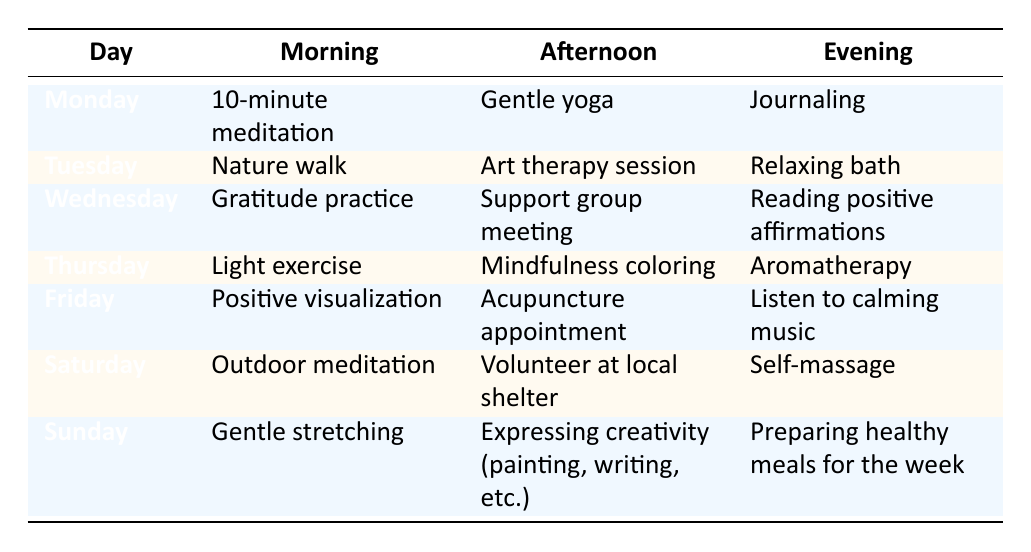What self-care activity is scheduled for Monday evening? By looking at the evening column for Monday, the activity listed is "Journaling."
Answer: Journaling Which day includes both a nature walk and an art therapy session? In the table, "Nature walk" is scheduled for Tuesday morning and "Art therapy session" is scheduled for Tuesday afternoon, indicating that both are on the same day.
Answer: Tuesday Is there a support group meeting scheduled for the week? The table shows that there is a "Support group meeting" on Wednesday afternoon, so the answer is yes.
Answer: Yes On which day is the 10-minute meditation scheduled? Referring to the morning column, "10-minute meditation" is scheduled for Monday, thus indicating the specific day.
Answer: Monday What is the average number of self-care activities completed in the evening for the week? Each day has one evening activity, and there are 7 days in the week. Therefore, the average is 7/7 = 1 activity per day.
Answer: 1 Which day features both outdoor meditation and volunteering at a local shelter? By reviewing the table, "Outdoor meditation" occurs on Saturday morning and "Volunteer at local shelter" happens on Saturday afternoon, meaning they are both on Saturday.
Answer: Saturday Are there any days that feature mindfulness coloring? The table reveals that "Mindfulness coloring" is scheduled for Thursday afternoon, confirming that it happens on that day.
Answer: Yes What evening activity is done after a gentle yoga session? Gentle yoga is scheduled for Monday afternoon, and the evening activity on that day is "Journaling," which occurs afterward.
Answer: Journaling On which days is a relaxation technique scheduled in the afternoon? Examining the table, relaxation techniques include "Art therapy session" on Tuesday and "Aromatherapy" on Thursday. Thus, the days are Tuesday and Thursday.
Answer: Tuesday, Thursday 